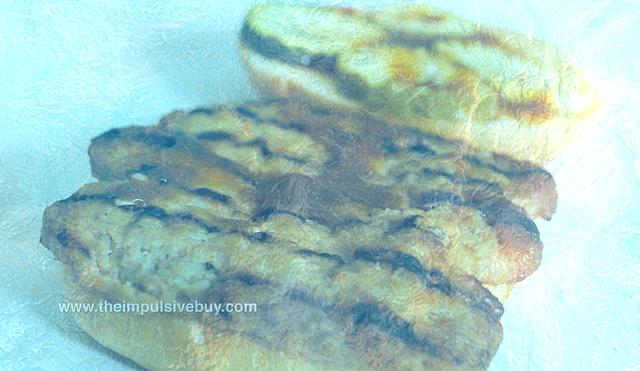What are some likely uses for the bread shown in the image? The loaf of bread in the image, with its hearty crust and ample size, seems ideal for various purposes. It could be sliced for sandwiches, torn for dipping in hearty stews, or served as a side with a variety of meals, complementing both savory and sweet accompaniments. 